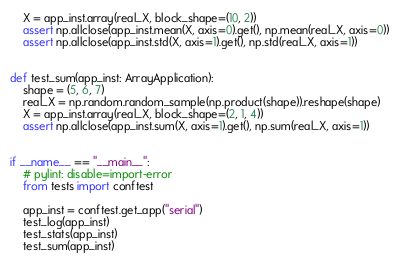<code> <loc_0><loc_0><loc_500><loc_500><_Python_>    X = app_inst.array(real_X, block_shape=(10, 2))
    assert np.allclose(app_inst.mean(X, axis=0).get(), np.mean(real_X, axis=0))
    assert np.allclose(app_inst.std(X, axis=1).get(), np.std(real_X, axis=1))


def test_sum(app_inst: ArrayApplication):
    shape = (5, 6, 7)
    real_X = np.random.random_sample(np.product(shape)).reshape(shape)
    X = app_inst.array(real_X, block_shape=(2, 1, 4))
    assert np.allclose(app_inst.sum(X, axis=1).get(), np.sum(real_X, axis=1))


if __name__ == "__main__":
    # pylint: disable=import-error
    from tests import conftest

    app_inst = conftest.get_app("serial")
    test_log(app_inst)
    test_stats(app_inst)
    test_sum(app_inst)
</code> 